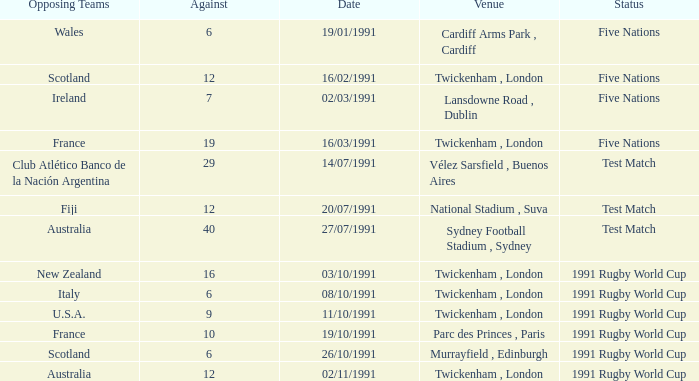What is Venue, when Status is "Test Match", and when Against is "12"? National Stadium , Suva. 